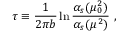Convert formula to latex. <formula><loc_0><loc_0><loc_500><loc_500>\tau \equiv \frac { 1 } { 2 \pi b } \ln \frac { \alpha _ { s } ( \mu _ { 0 } ^ { 2 } ) } { \alpha _ { s } ( \mu ^ { 2 } ) } \ ,</formula> 